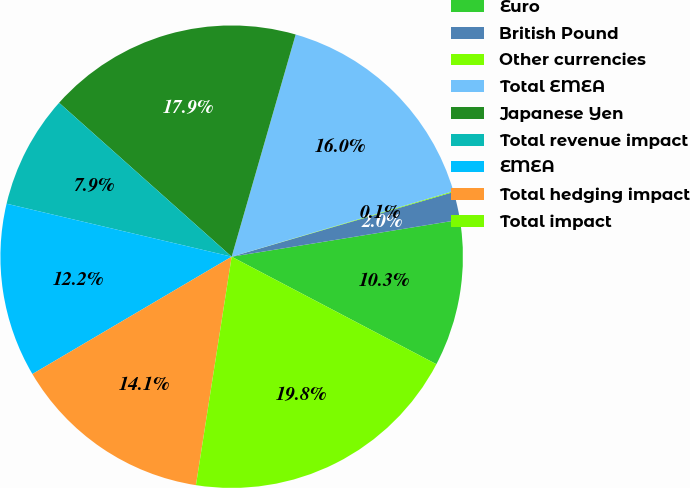Convert chart. <chart><loc_0><loc_0><loc_500><loc_500><pie_chart><fcel>Euro<fcel>British Pound<fcel>Other currencies<fcel>Total EMEA<fcel>Japanese Yen<fcel>Total revenue impact<fcel>EMEA<fcel>Total hedging impact<fcel>Total impact<nl><fcel>10.25%<fcel>1.96%<fcel>0.06%<fcel>15.96%<fcel>17.87%<fcel>7.91%<fcel>12.15%<fcel>14.06%<fcel>19.77%<nl></chart> 